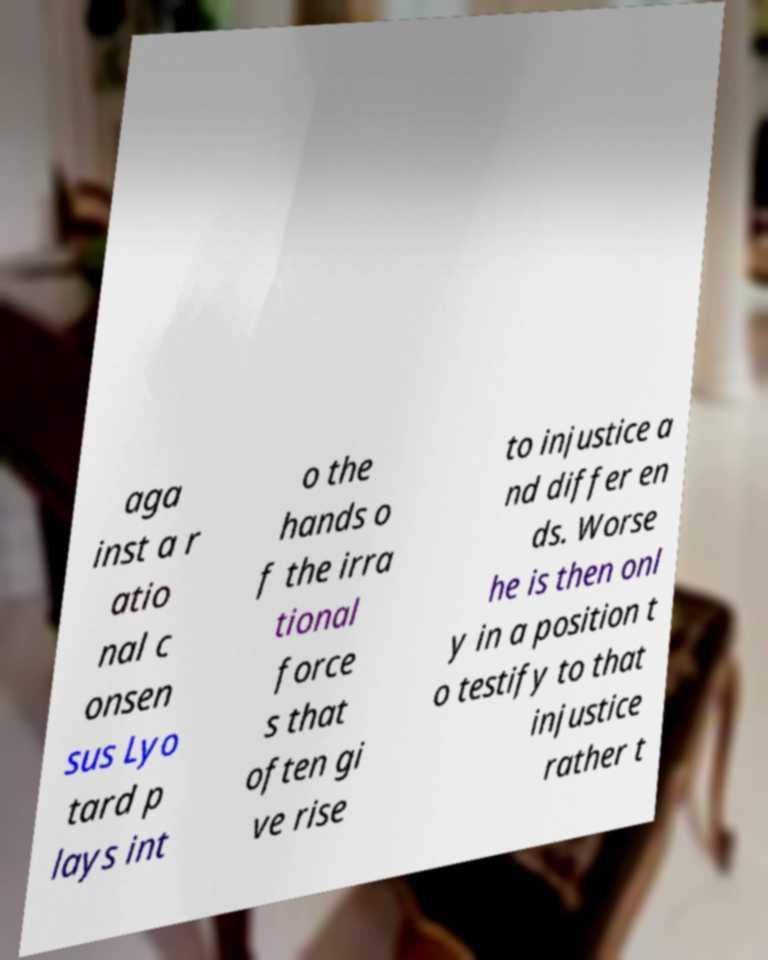Please identify and transcribe the text found in this image. aga inst a r atio nal c onsen sus Lyo tard p lays int o the hands o f the irra tional force s that often gi ve rise to injustice a nd differ en ds. Worse he is then onl y in a position t o testify to that injustice rather t 